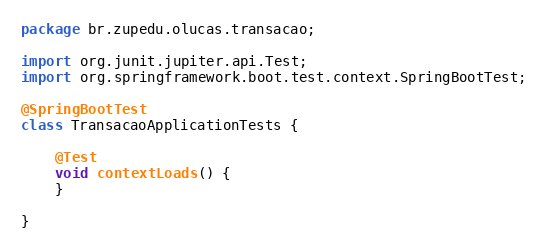<code> <loc_0><loc_0><loc_500><loc_500><_Java_>package br.zupedu.olucas.transacao;

import org.junit.jupiter.api.Test;
import org.springframework.boot.test.context.SpringBootTest;

@SpringBootTest
class TransacaoApplicationTests {

	@Test
	void contextLoads() {
	}

}
</code> 